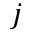<formula> <loc_0><loc_0><loc_500><loc_500>j</formula> 